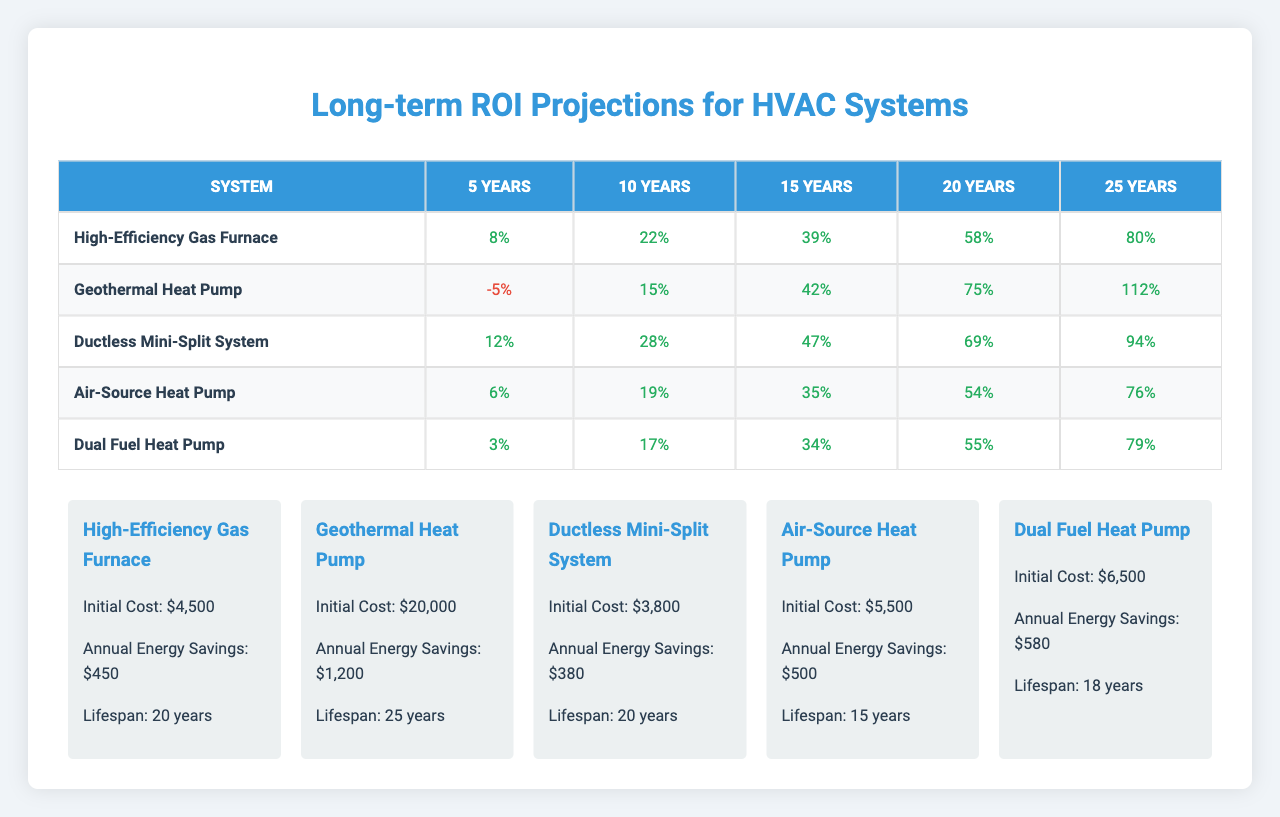What is the highest ROI projection after 25 years for any HVAC system? The highest ROI projection after 25 years is found by looking at the last column of the ROI table. The values for 25 years are 80, 112, 94, 76, and 79. The maximum value is 112, which corresponds to the Geothermal Heat Pump.
Answer: 112 What is the initial cost of the Ductless Mini-Split System? The initial cost can be found in the respective row for the Ductless Mini-Split System, which is listed as $3,800.
Answer: $3,800 Do any systems have a negative ROI after 5 years? By examining the first column of the ROI table, we see that the High-Efficiency Gas Furnace has 8, Geothermal Heat Pump has -5, Ductless Mini-Split has 12, Air-Source Heat Pump has 6, and Dual Fuel Heat Pump has 3. The Geothermal Heat Pump is the only one with a negative ROI.
Answer: Yes What is the average ROI projection for the Air-Source Heat Pump over 20 years? The ROI values for the Air-Source Heat Pump over 20 years are 6%, 19%, 35%, 54%, and 76%. Summing them up gives 6 + 19 + 35 + 54 + 76 = 190. Dividing by the number of years (5) gives an average of 190/5 = 38%.
Answer: 38% Which HVAC system provides the best annual energy savings? By comparing the annual energy savings of all systems, we find the values: 450 for High-Efficiency Gas Furnace, 1200 for Geothermal Heat Pump, 380 for Ductless Mini-Split, 500 for Air-Source Heat Pump, and 580 for Dual Fuel Heat Pump. The highest value is 1200, for the Geothermal Heat Pump.
Answer: 1200 After 15 years, how much ROI does the Dual Fuel Heat Pump provide? Looking at the ROI column for 15 years for the Dual Fuel Heat Pump, it is noted as 34%.
Answer: 34% How does the ROI of the Geothermal Heat Pump compare to the Air-Source Heat Pump after 10 years? The Geothermal Heat Pump has an ROI of 15% after 10 years, while the Air-Source Heat Pump has an ROI of 19%. Since 19% is higher than 15%, the Air-Source Heat Pump has a better ROI.
Answer: Air-Source Heat Pump has a better ROI Is the lifespan of the High-Efficiency Gas Furnace greater than 20 years? The lifespan of the High-Efficiency Gas Furnace is listed as 20 years. Therefore, it is not greater than 20 years since it is equal to 20.
Answer: No What is the total ROI over the first 5 years for the Ductless Mini-Split System? The total ROI over the first 5 years includes the following percentages: 12%, 28%, 47%, 69%, and 94%. Adding these values gives 12 + 28 + 47 + 69 + 94 = 250%.
Answer: 250% Which system has the lowest ROI projection after 25 years? Reviewing the ROI projections for 25 years, we see the values are 80, 112, 94, 76, and 79. The lowest among these is 76%, corresponding to the Air-Source Heat Pump.
Answer: Air-Source Heat Pump 